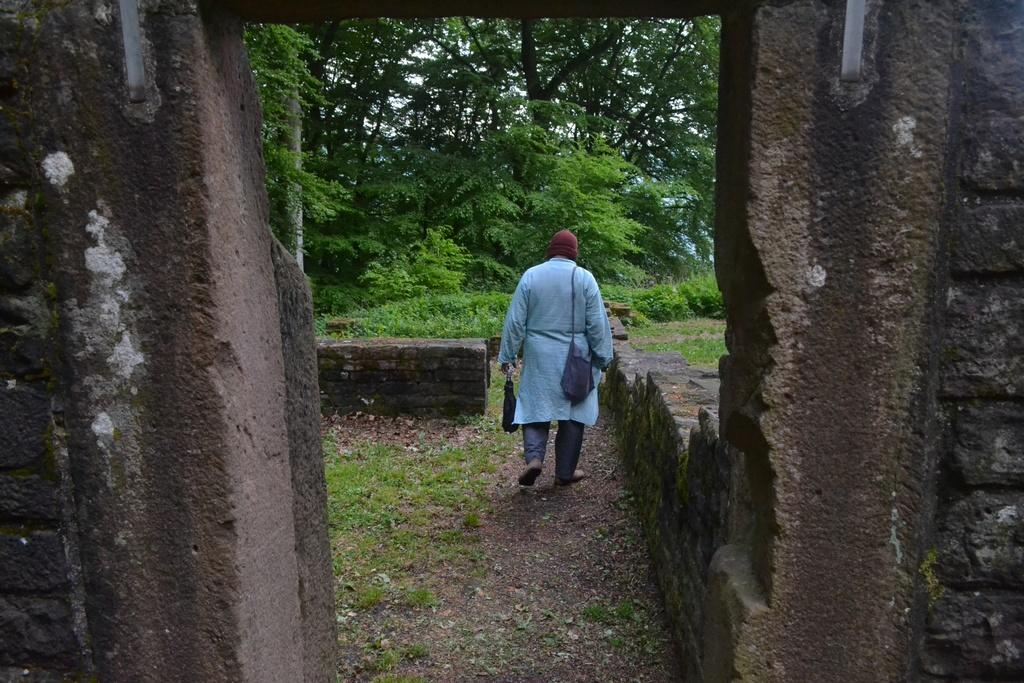What can be seen in the background of the image? There are many trees and the sky visible in the background of the image. What is the person in the image wearing? The person is wearing a dress. What is the person holding in the image? The person is holding a bag and something else. What is the something else that the person is holding? The person is holding a bag and a book. Can you see any cables hanging from the trees in the image? There are no cables visible in the image; it only shows a person, a wall, and trees in the background. 